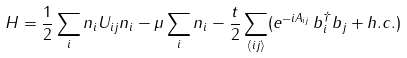Convert formula to latex. <formula><loc_0><loc_0><loc_500><loc_500>H = \frac { 1 } { 2 } \sum _ { i } n _ { i } U _ { i j } n _ { i } - \mu \sum _ { i } n _ { i } - \frac { t } { 2 } \sum _ { \langle i j \rangle } ( e ^ { - i A _ { i j } } \, b ^ { \dagger } _ { i } b _ { j } + h . c . )</formula> 